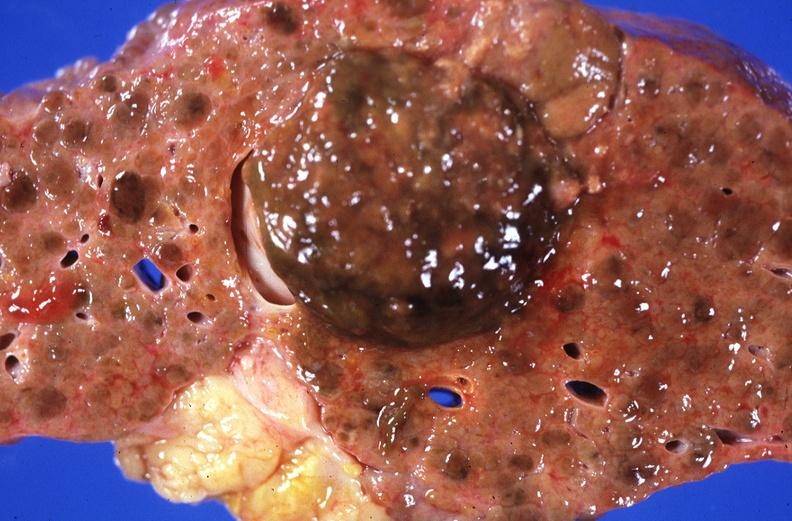s hepatobiliary present?
Answer the question using a single word or phrase. Yes 